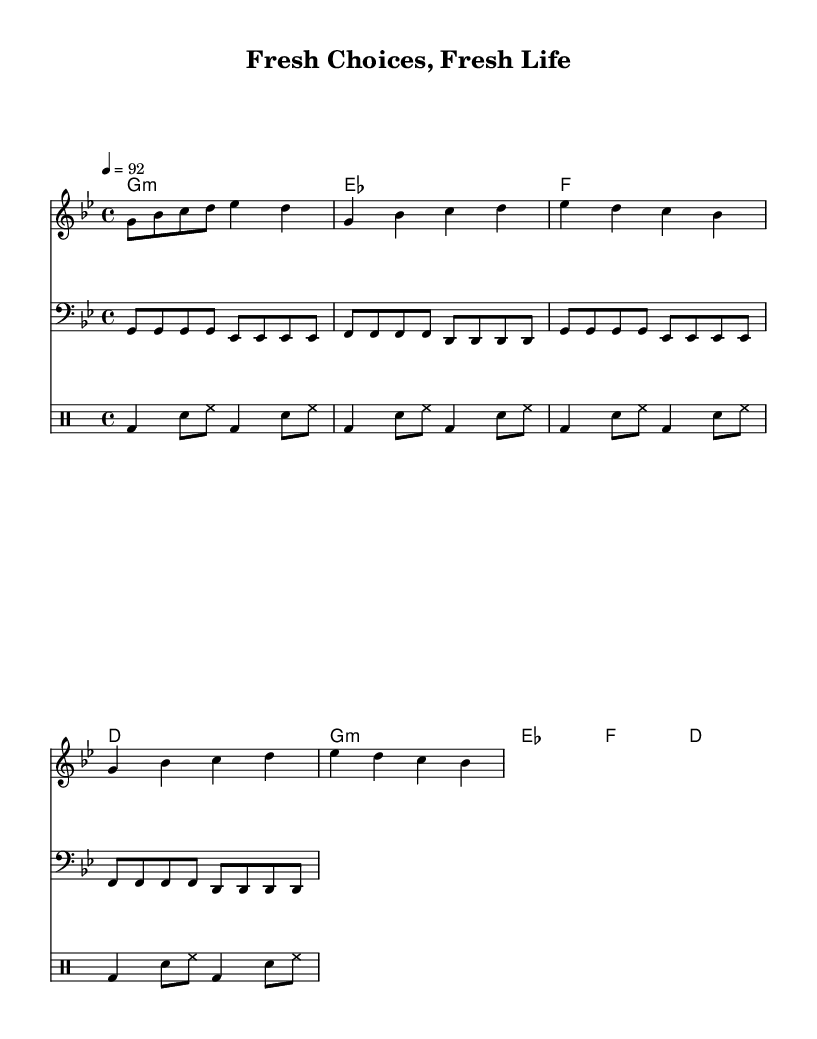What is the key signature of this music? The key signature is G minor, which has two flats (B flat and E flat). This can be determined from the global music settings indicated at the beginning of the score.
Answer: G minor What is the time signature of the music? The time signature is 4/4, which means there are four beats in each measure and the quarter note gets one beat. This is specified at the beginning of the score.
Answer: 4/4 What is the tempo marking in the music? The tempo marking indicates a speed of 92 beats per minute, denoted at the start of the score with "4 = 92". This means each quarter note is played at this speed.
Answer: 92 How many measures are in the chorus section? The chorus section consists of four measures as can be visually counted in the repeated passage for the chorus, which is also marked for repetition in the sheet music.
Answer: 4 What is the primary theme expressed in the lyrics? The primary theme in the lyrics highlights making healthier food choices to improve one's lifestyle, which is evident from the repeated phrases about fresh food and self-improvement throughout the verses and chorus.
Answer: Healthy food choices What is the rhythmic pattern in the drum section? The rhythmic pattern in the drum section consists of a repeating sequence of bass drum, snare, and hi-hat, where the bass drum is played on the first and third beats with alternating snare and hi-hat on the off-beats. This pattern can be seen in the detailed drum notation provided.
Answer: Bass-snare-hi-hat How does the melody change from the verse to the chorus? The melody remains consistent in terms of structure but changes in pitch within the repeated phrases, emphasizing the motivational theme of the chorus compared to the verse. This is indicated through the melody notation for both sections in the score.
Answer: Consistent structure, different pitch 